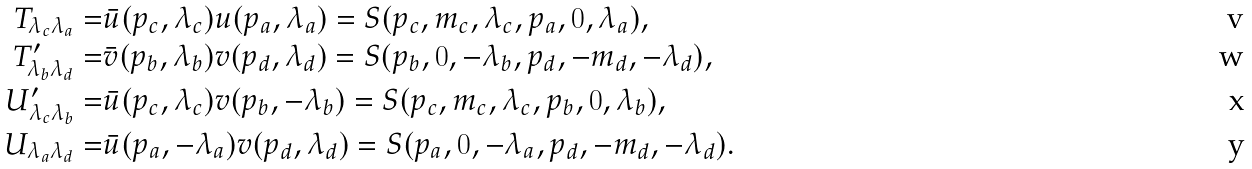Convert formula to latex. <formula><loc_0><loc_0><loc_500><loc_500>T _ { \lambda _ { c } \lambda _ { a } } = & \bar { u } ( p _ { c } , \lambda _ { c } ) u ( p _ { a } , \lambda _ { a } ) = S ( p _ { c } , m _ { c } , \lambda _ { c } , p _ { a } , 0 , \lambda _ { a } ) , \\ T ^ { \prime } _ { \lambda _ { b } \lambda _ { d } } = & \bar { v } ( p _ { b } , \lambda _ { b } ) v ( p _ { d } , \lambda _ { d } ) = S ( p _ { b } , 0 , - \lambda _ { b } , p _ { d } , - m _ { d } , - \lambda _ { d } ) , \\ U ^ { \prime } _ { \lambda _ { c } \lambda _ { b } } = & \bar { u } ( p _ { c } , \lambda _ { c } ) v ( p _ { b } , - \lambda _ { b } ) = S ( p _ { c } , m _ { c } , \lambda _ { c } , p _ { b } , 0 , \lambda _ { b } ) , \\ U _ { \lambda _ { a } \lambda _ { d } } = & \bar { u } ( p _ { a } , - \lambda _ { a } ) v ( p _ { d } , \lambda _ { d } ) = S ( p _ { a } , 0 , - \lambda _ { a } , p _ { d } , - m _ { d } , - \lambda _ { d } ) .</formula> 